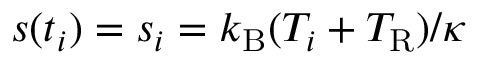Convert formula to latex. <formula><loc_0><loc_0><loc_500><loc_500>s ( t _ { i } ) = s _ { i } = k _ { B } ( T _ { i } + T _ { R } ) / \kappa</formula> 